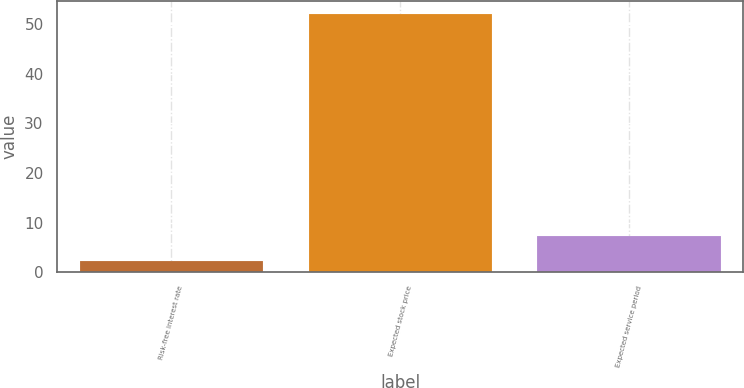Convert chart. <chart><loc_0><loc_0><loc_500><loc_500><bar_chart><fcel>Risk-free interest rate<fcel>Expected stock price<fcel>Expected service period<nl><fcel>2.3<fcel>52.1<fcel>7.28<nl></chart> 